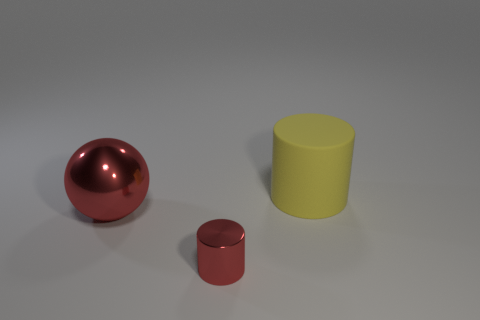Can you describe the atmosphere or mood of this image? The image has a minimalist and clean aesthetic, producing a tranquil and modern atmosphere. The simplicity of the shapes and the monochromatic background contribute to a peaceful and uncluttered mood.  Are these objects functional in any way, or are they purely decorative? While the objects have a simplistic elegance that could serve as modern decor, without additional context it's not clear if they have a functional purpose. In a different setting, they might be components of a larger system or could indeed be meant for decoration. 